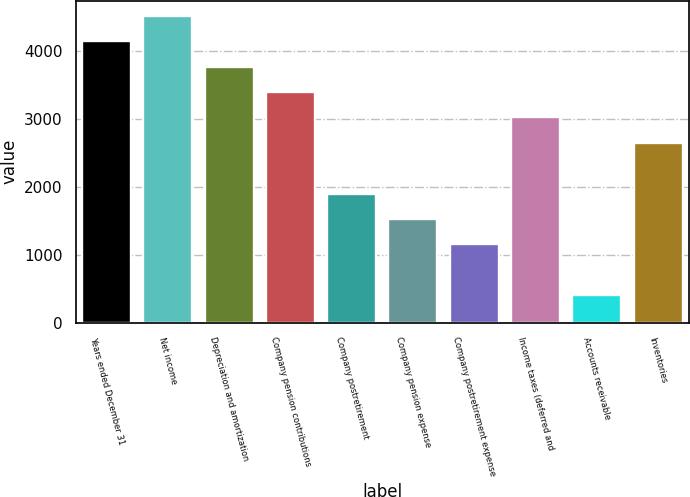Convert chart. <chart><loc_0><loc_0><loc_500><loc_500><bar_chart><fcel>Years ended December 31<fcel>Net income<fcel>Depreciation and amortization<fcel>Company pension contributions<fcel>Company postretirement<fcel>Company pension expense<fcel>Company postretirement expense<fcel>Income taxes (deferred and<fcel>Accounts receivable<fcel>Inventories<nl><fcel>4146.8<fcel>4520.6<fcel>3773<fcel>3399.2<fcel>1904<fcel>1530.2<fcel>1156.4<fcel>3025.4<fcel>408.8<fcel>2651.6<nl></chart> 